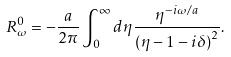<formula> <loc_0><loc_0><loc_500><loc_500>R _ { \omega } ^ { 0 } = - \frac { a } { 2 \pi } \int _ { 0 } ^ { \infty } d \eta \frac { \eta ^ { - i \omega / a } } { \left ( \eta - 1 - i \delta \right ) ^ { 2 } } .</formula> 